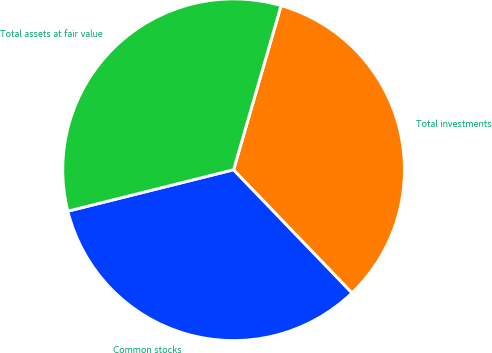<chart> <loc_0><loc_0><loc_500><loc_500><pie_chart><fcel>Common stocks<fcel>Total investments<fcel>Total assets at fair value<nl><fcel>33.29%<fcel>33.33%<fcel>33.38%<nl></chart> 